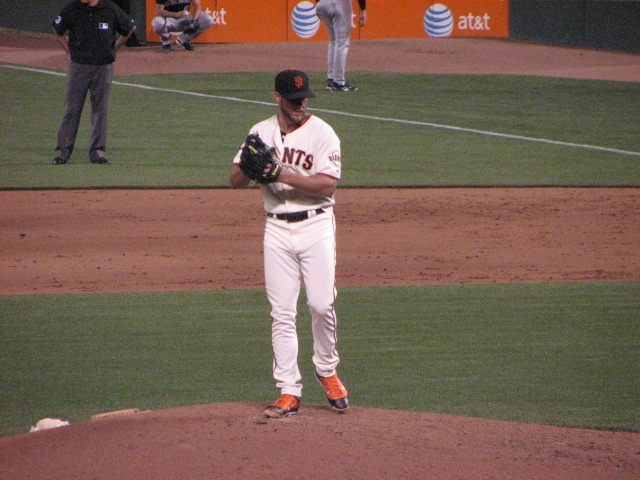Describe the objects in this image and their specific colors. I can see people in black, lavender, gray, and brown tones, people in black and gray tones, people in black, gray, and brown tones, people in black, gray, brown, and maroon tones, and baseball glove in black, gray, and purple tones in this image. 